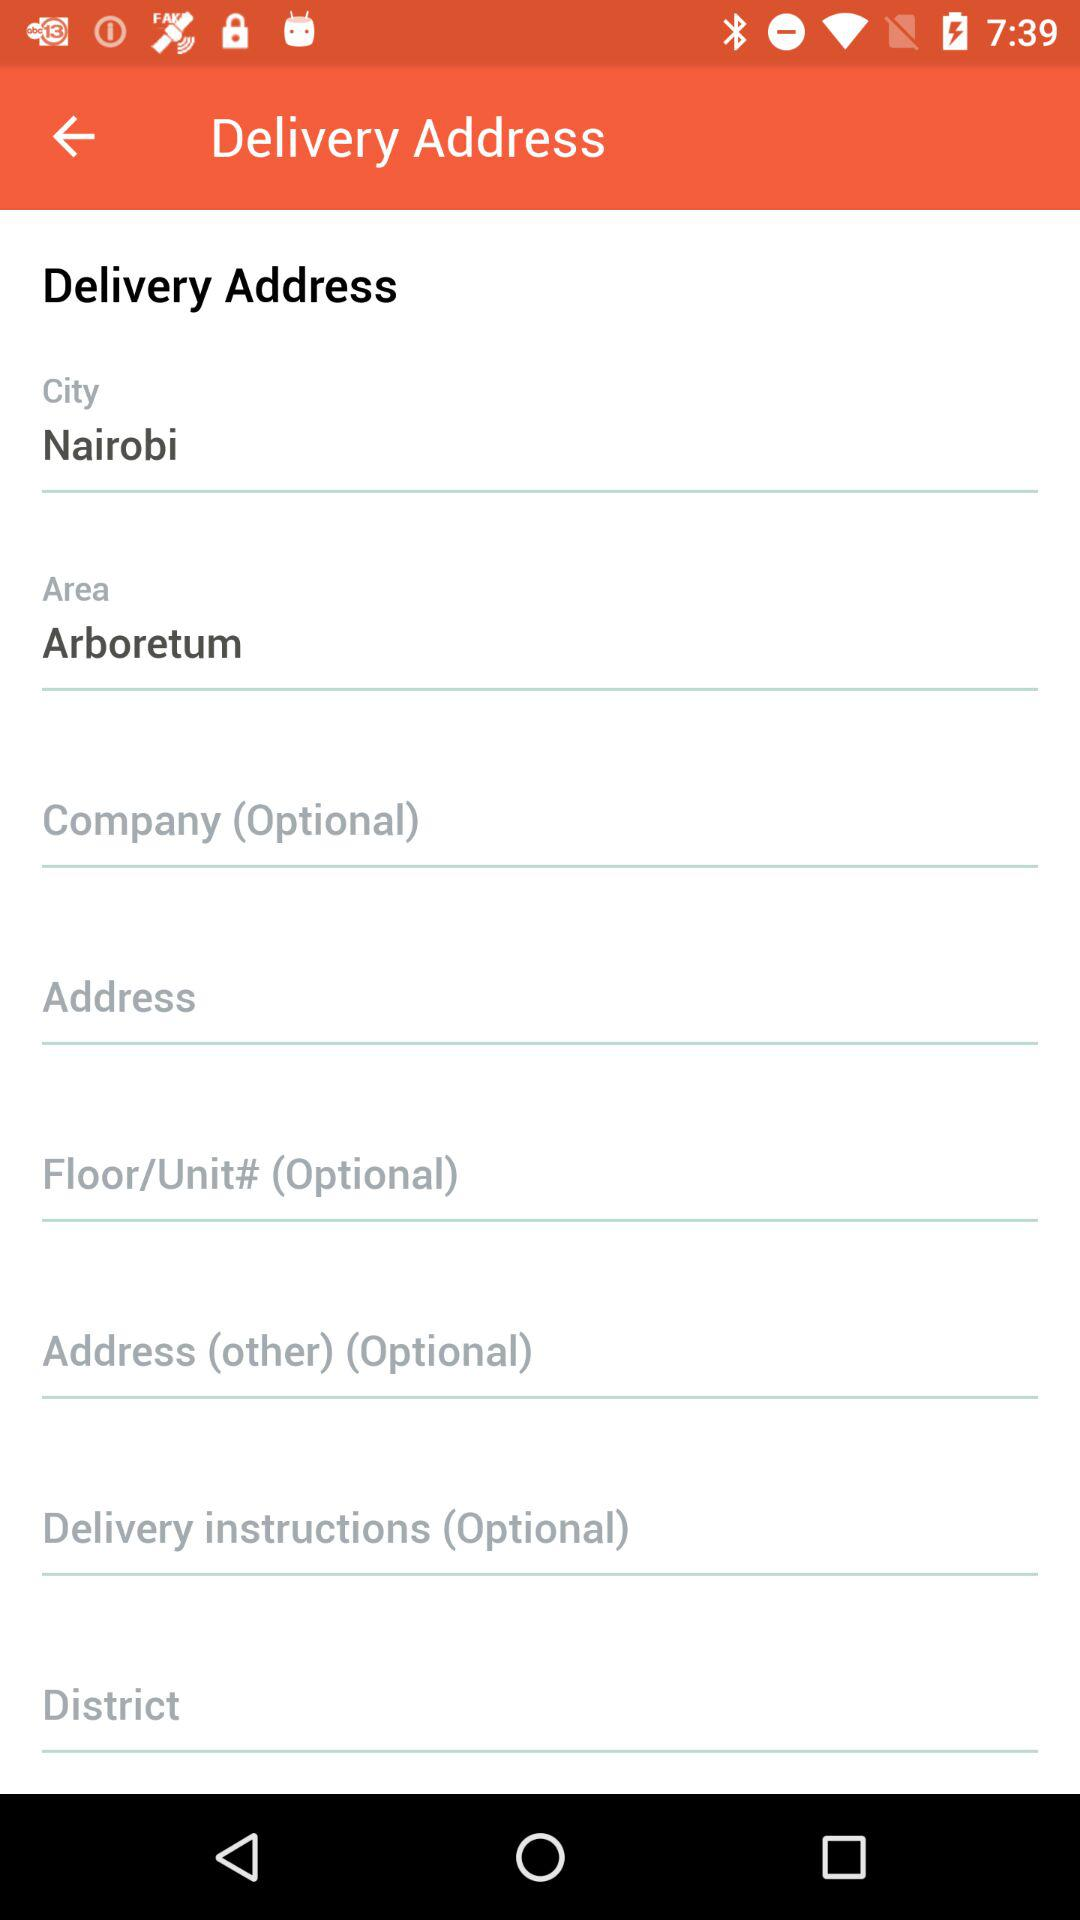What is the area name? The area name is Arboretum. 